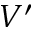<formula> <loc_0><loc_0><loc_500><loc_500>V ^ { \prime }</formula> 